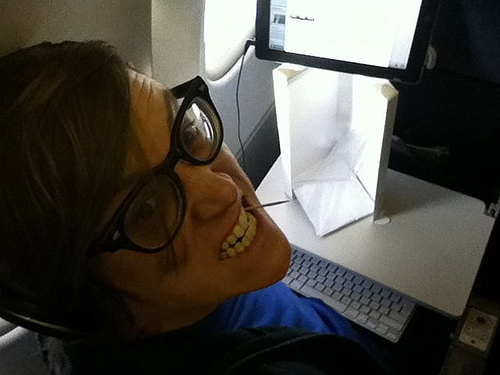Describe the environment around the guy. The environment around the guy seems to be inside a plane or a compact space with a screen and a keyboard in front of him, possibly indicating he is working or playing a game. 